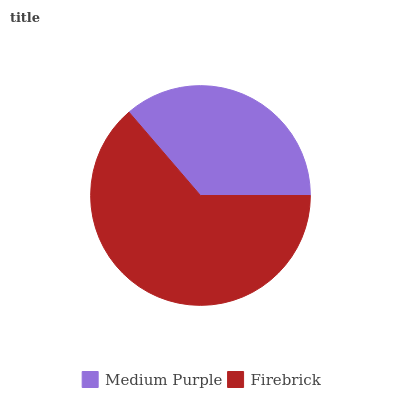Is Medium Purple the minimum?
Answer yes or no. Yes. Is Firebrick the maximum?
Answer yes or no. Yes. Is Firebrick the minimum?
Answer yes or no. No. Is Firebrick greater than Medium Purple?
Answer yes or no. Yes. Is Medium Purple less than Firebrick?
Answer yes or no. Yes. Is Medium Purple greater than Firebrick?
Answer yes or no. No. Is Firebrick less than Medium Purple?
Answer yes or no. No. Is Firebrick the high median?
Answer yes or no. Yes. Is Medium Purple the low median?
Answer yes or no. Yes. Is Medium Purple the high median?
Answer yes or no. No. Is Firebrick the low median?
Answer yes or no. No. 